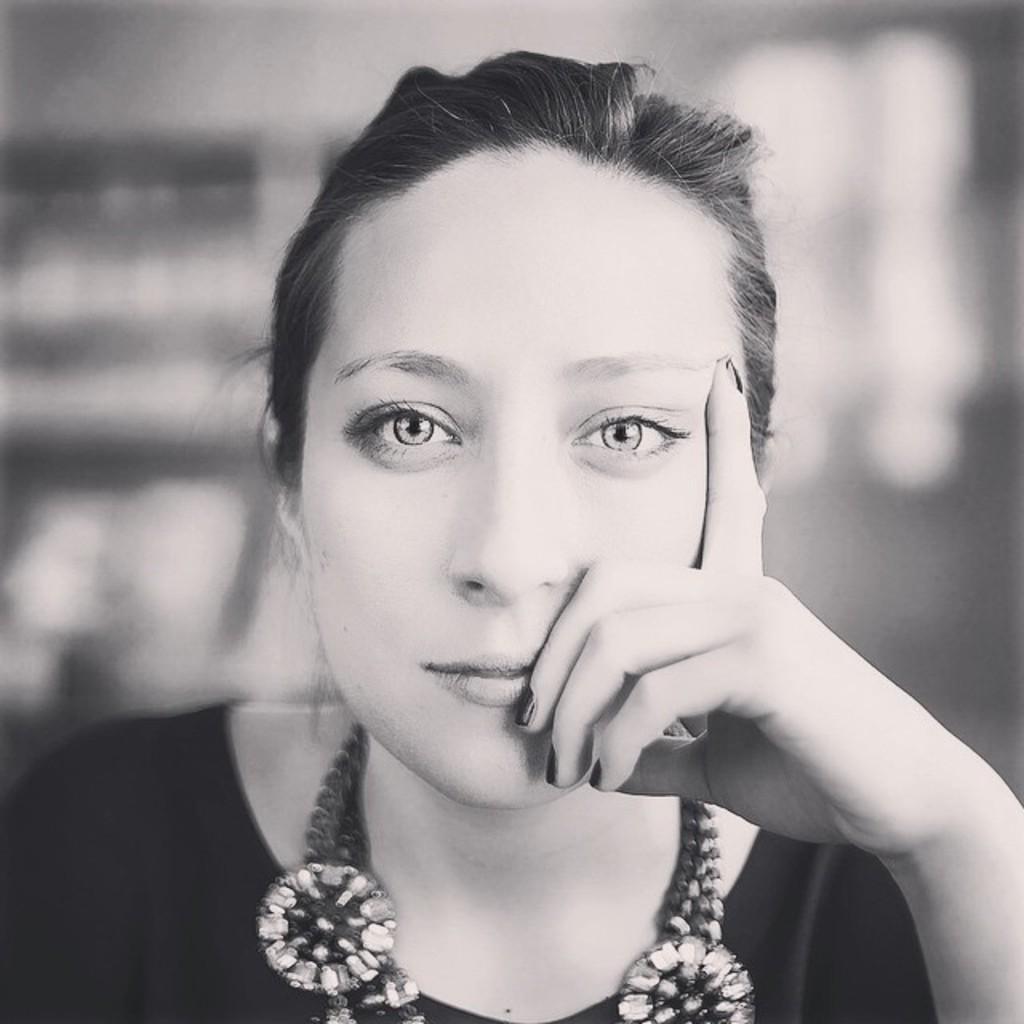Please provide a concise description of this image. In this black and white image there is a woman. The background is blurry. 